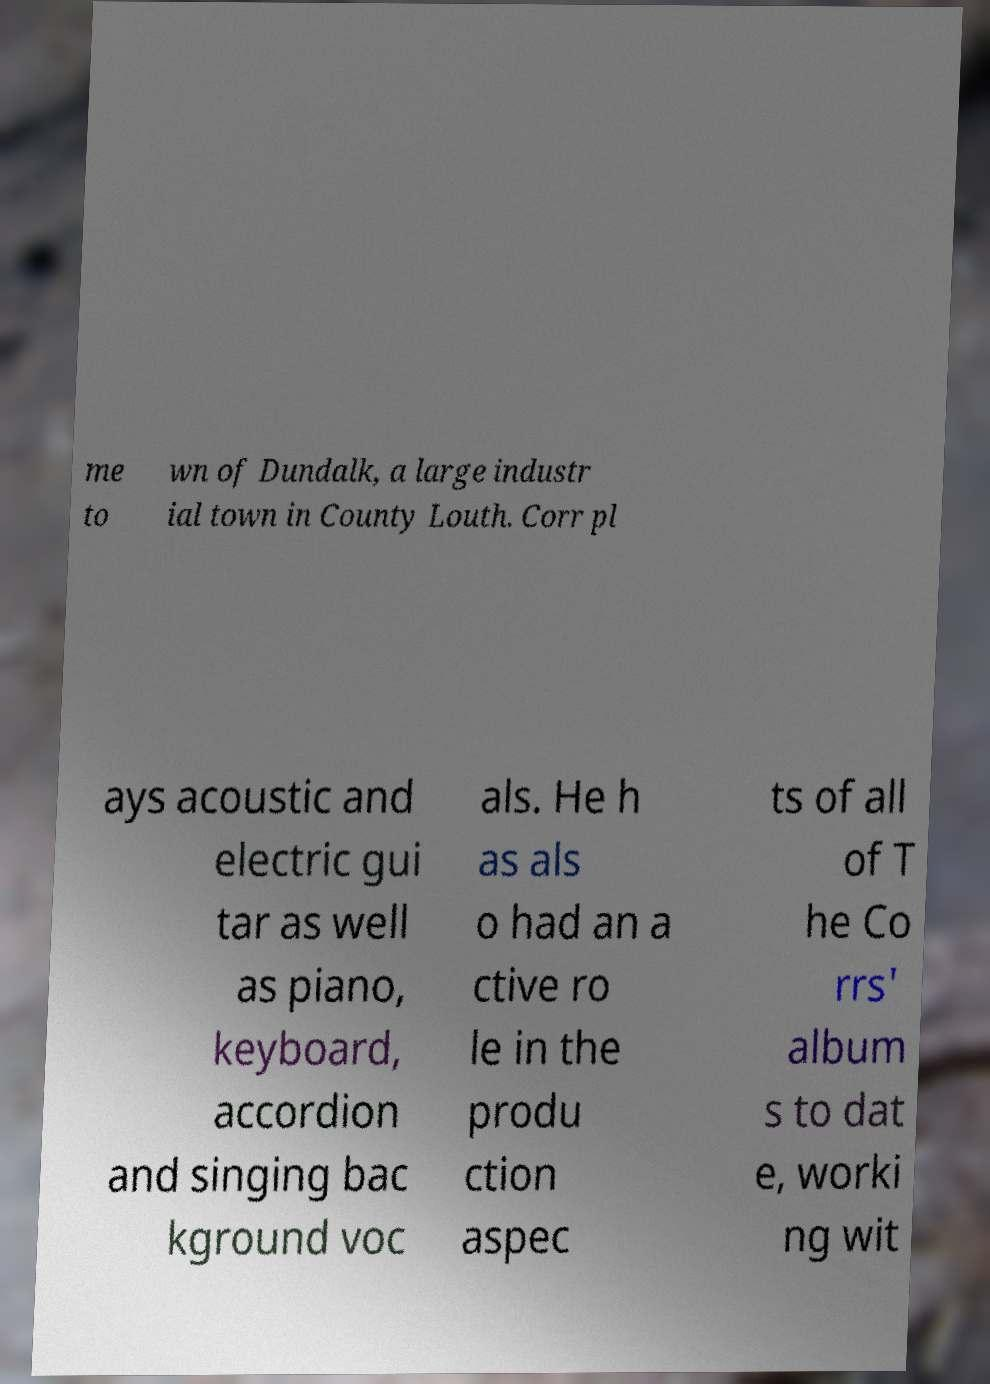Could you extract and type out the text from this image? me to wn of Dundalk, a large industr ial town in County Louth. Corr pl ays acoustic and electric gui tar as well as piano, keyboard, accordion and singing bac kground voc als. He h as als o had an a ctive ro le in the produ ction aspec ts of all of T he Co rrs' album s to dat e, worki ng wit 